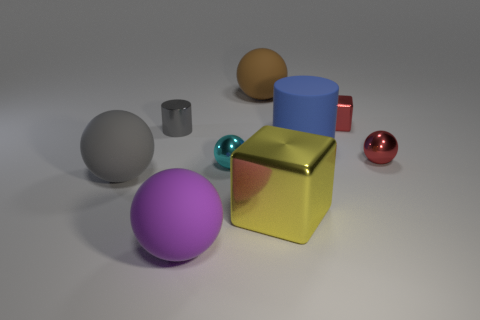What is the texture of the purple ball compared to the red ball? The purple ball has a matte finish, which is less reflective and appears smoother, in contrast to the red ball's glossy, reflective surface. 